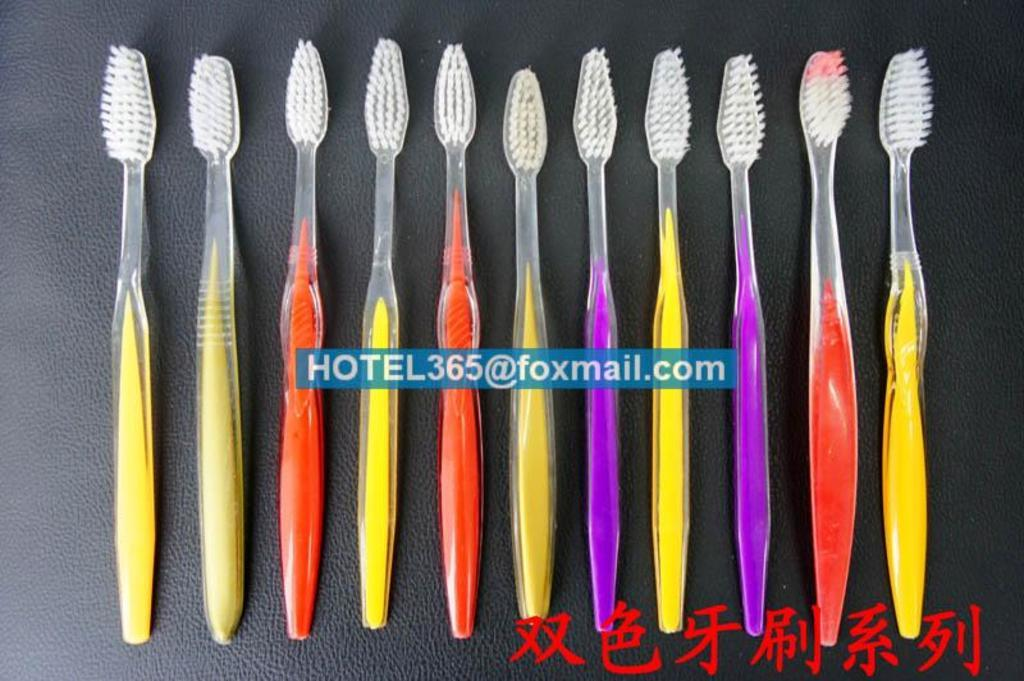What objects are on the surface in the image? There are brushes on a surface in the image. What can be seen in the middle of the image? There is a watermark in the middle of the image. What is located at the bottom of the image? There is text at the bottom of the image. How many levels can be seen in the image? There are no levels present in the image. 